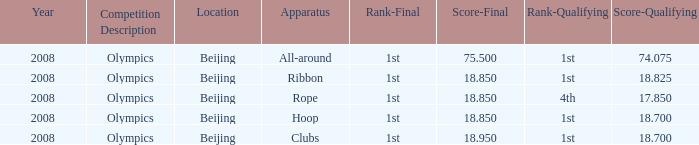What was her lowest final score with a qualifying score of 74.075? 75.5. 